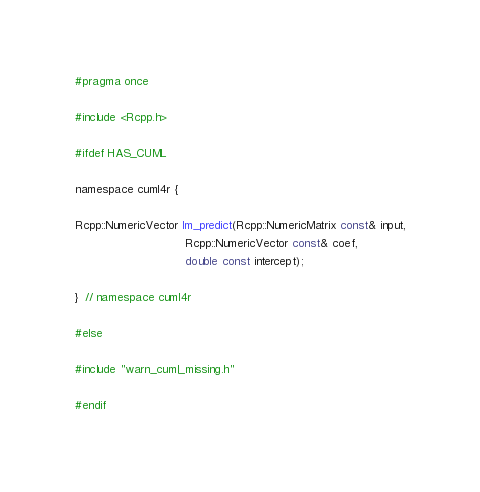Convert code to text. <code><loc_0><loc_0><loc_500><loc_500><_C_>#pragma once

#include <Rcpp.h>

#ifdef HAS_CUML

namespace cuml4r {

Rcpp::NumericVector lm_predict(Rcpp::NumericMatrix const& input,
                               Rcpp::NumericVector const& coef,
                               double const intercept);

}  // namespace cuml4r

#else

#include "warn_cuml_missing.h"

#endif
</code> 